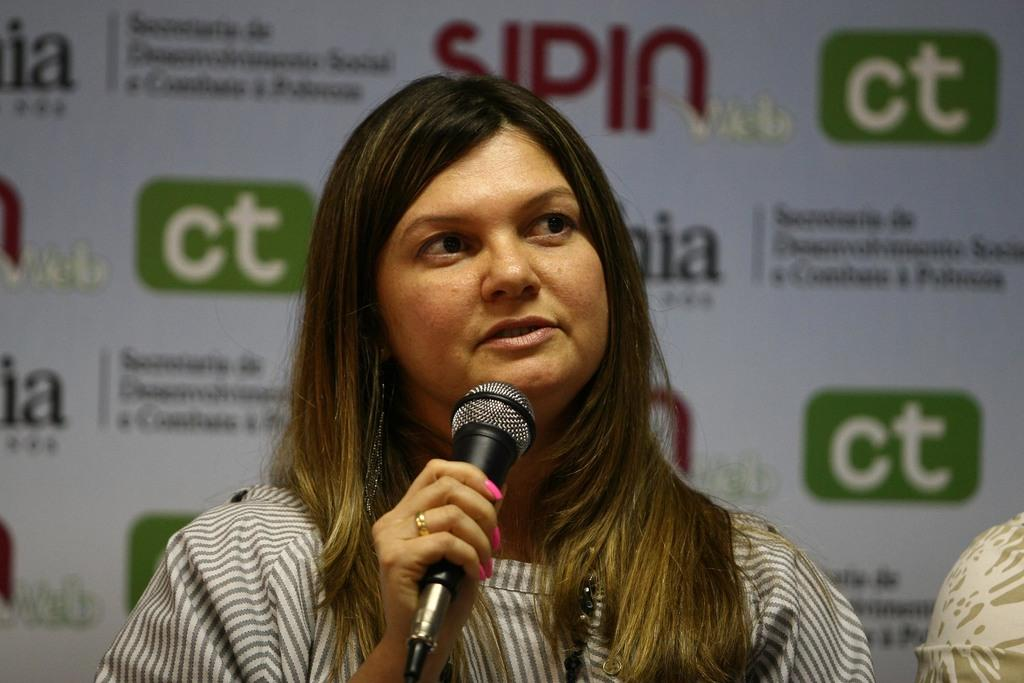Who is the main subject in the image? There is a woman in the image. What is the woman holding in her hand? The woman is holding a mic in her hand. What can be seen in the background of the image? There is a banner in the background of the image. What is the purpose of the orange in the image? There is no orange present in the image, so it cannot be used for any purpose within the context of the image. 